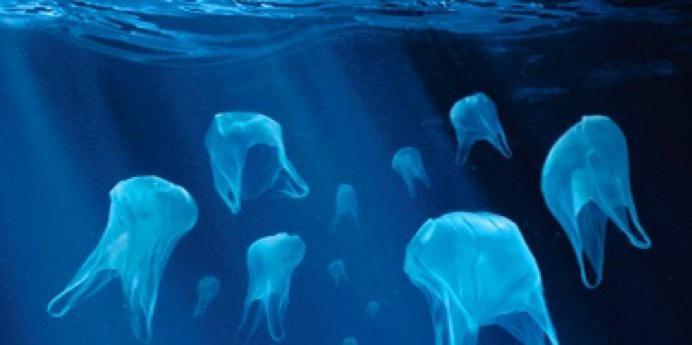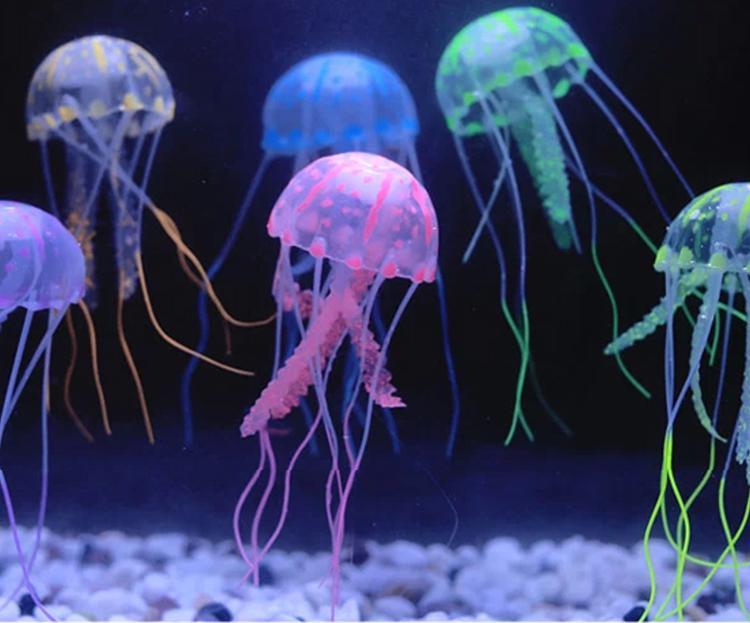The first image is the image on the left, the second image is the image on the right. Considering the images on both sides, is "Each image features different colors of jellyfish with long tentacles dangling downward, and the right image features jellyfish in an aquarium tank with green plants." valid? Answer yes or no. No. The first image is the image on the left, the second image is the image on the right. Assess this claim about the two images: "One image in the pair shows jellyfish of all one color while the other shows jellyfish in a variety of colors.". Correct or not? Answer yes or no. Yes. 